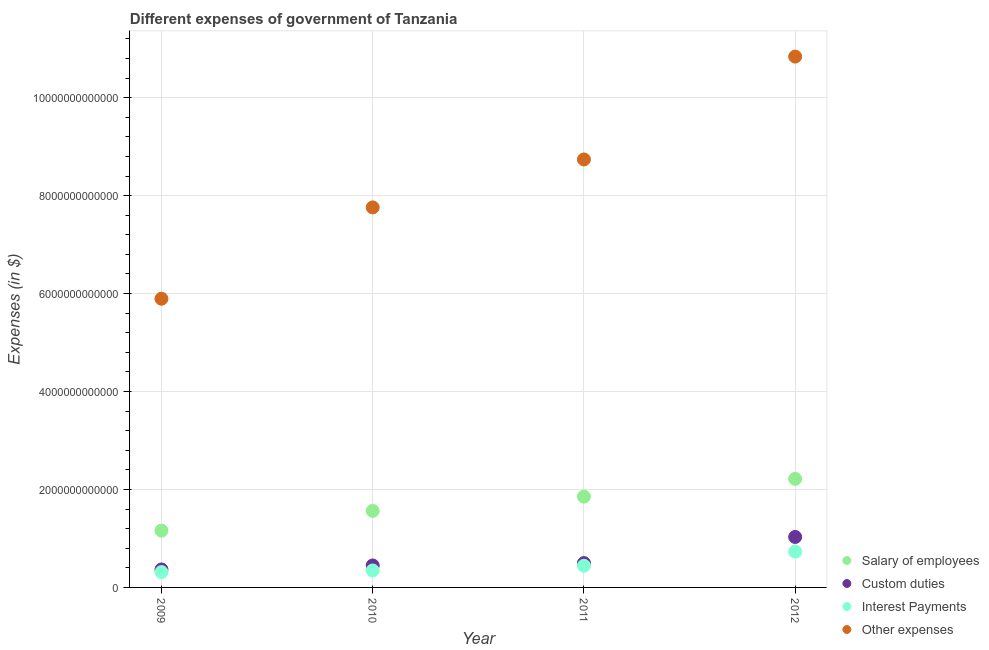How many different coloured dotlines are there?
Your response must be concise. 4. What is the amount spent on interest payments in 2009?
Provide a short and direct response. 3.14e+11. Across all years, what is the maximum amount spent on salary of employees?
Offer a very short reply. 2.22e+12. Across all years, what is the minimum amount spent on interest payments?
Offer a very short reply. 3.14e+11. In which year was the amount spent on other expenses minimum?
Offer a terse response. 2009. What is the total amount spent on salary of employees in the graph?
Provide a succinct answer. 6.79e+12. What is the difference between the amount spent on other expenses in 2010 and that in 2012?
Offer a very short reply. -3.08e+12. What is the difference between the amount spent on salary of employees in 2010 and the amount spent on other expenses in 2009?
Your answer should be compact. -4.33e+12. What is the average amount spent on salary of employees per year?
Your answer should be compact. 1.70e+12. In the year 2010, what is the difference between the amount spent on custom duties and amount spent on other expenses?
Give a very brief answer. -7.31e+12. In how many years, is the amount spent on salary of employees greater than 10000000000000 $?
Keep it short and to the point. 0. What is the ratio of the amount spent on interest payments in 2011 to that in 2012?
Your answer should be compact. 0.61. Is the amount spent on other expenses in 2009 less than that in 2010?
Your answer should be very brief. Yes. Is the difference between the amount spent on interest payments in 2010 and 2011 greater than the difference between the amount spent on other expenses in 2010 and 2011?
Offer a very short reply. Yes. What is the difference between the highest and the second highest amount spent on custom duties?
Give a very brief answer. 5.33e+11. What is the difference between the highest and the lowest amount spent on other expenses?
Your response must be concise. 4.94e+12. In how many years, is the amount spent on interest payments greater than the average amount spent on interest payments taken over all years?
Offer a terse response. 1. Is the sum of the amount spent on other expenses in 2010 and 2012 greater than the maximum amount spent on interest payments across all years?
Give a very brief answer. Yes. Is it the case that in every year, the sum of the amount spent on custom duties and amount spent on salary of employees is greater than the sum of amount spent on interest payments and amount spent on other expenses?
Offer a very short reply. No. Does the amount spent on other expenses monotonically increase over the years?
Keep it short and to the point. Yes. Is the amount spent on other expenses strictly greater than the amount spent on interest payments over the years?
Provide a succinct answer. Yes. Is the amount spent on interest payments strictly less than the amount spent on custom duties over the years?
Give a very brief answer. Yes. How many dotlines are there?
Offer a very short reply. 4. How many years are there in the graph?
Your answer should be compact. 4. What is the difference between two consecutive major ticks on the Y-axis?
Keep it short and to the point. 2.00e+12. Are the values on the major ticks of Y-axis written in scientific E-notation?
Offer a very short reply. No. Does the graph contain any zero values?
Your answer should be compact. No. Does the graph contain grids?
Give a very brief answer. Yes. How many legend labels are there?
Your answer should be compact. 4. How are the legend labels stacked?
Offer a very short reply. Vertical. What is the title of the graph?
Ensure brevity in your answer.  Different expenses of government of Tanzania. What is the label or title of the Y-axis?
Provide a succinct answer. Expenses (in $). What is the Expenses (in $) in Salary of employees in 2009?
Your response must be concise. 1.16e+12. What is the Expenses (in $) in Custom duties in 2009?
Provide a succinct answer. 3.67e+11. What is the Expenses (in $) in Interest Payments in 2009?
Make the answer very short. 3.14e+11. What is the Expenses (in $) in Other expenses in 2009?
Provide a succinct answer. 5.89e+12. What is the Expenses (in $) in Salary of employees in 2010?
Your answer should be compact. 1.56e+12. What is the Expenses (in $) in Custom duties in 2010?
Ensure brevity in your answer.  4.49e+11. What is the Expenses (in $) of Interest Payments in 2010?
Your answer should be very brief. 3.47e+11. What is the Expenses (in $) in Other expenses in 2010?
Keep it short and to the point. 7.76e+12. What is the Expenses (in $) in Salary of employees in 2011?
Your answer should be compact. 1.85e+12. What is the Expenses (in $) of Custom duties in 2011?
Provide a succinct answer. 4.98e+11. What is the Expenses (in $) in Interest Payments in 2011?
Provide a short and direct response. 4.43e+11. What is the Expenses (in $) of Other expenses in 2011?
Keep it short and to the point. 8.74e+12. What is the Expenses (in $) of Salary of employees in 2012?
Your answer should be very brief. 2.22e+12. What is the Expenses (in $) of Custom duties in 2012?
Provide a short and direct response. 1.03e+12. What is the Expenses (in $) in Interest Payments in 2012?
Provide a short and direct response. 7.31e+11. What is the Expenses (in $) in Other expenses in 2012?
Keep it short and to the point. 1.08e+13. Across all years, what is the maximum Expenses (in $) of Salary of employees?
Ensure brevity in your answer.  2.22e+12. Across all years, what is the maximum Expenses (in $) of Custom duties?
Offer a very short reply. 1.03e+12. Across all years, what is the maximum Expenses (in $) of Interest Payments?
Ensure brevity in your answer.  7.31e+11. Across all years, what is the maximum Expenses (in $) in Other expenses?
Offer a very short reply. 1.08e+13. Across all years, what is the minimum Expenses (in $) of Salary of employees?
Your response must be concise. 1.16e+12. Across all years, what is the minimum Expenses (in $) of Custom duties?
Offer a terse response. 3.67e+11. Across all years, what is the minimum Expenses (in $) in Interest Payments?
Give a very brief answer. 3.14e+11. Across all years, what is the minimum Expenses (in $) of Other expenses?
Make the answer very short. 5.89e+12. What is the total Expenses (in $) of Salary of employees in the graph?
Give a very brief answer. 6.79e+12. What is the total Expenses (in $) of Custom duties in the graph?
Provide a succinct answer. 2.34e+12. What is the total Expenses (in $) of Interest Payments in the graph?
Give a very brief answer. 1.83e+12. What is the total Expenses (in $) of Other expenses in the graph?
Offer a terse response. 3.32e+13. What is the difference between the Expenses (in $) in Salary of employees in 2009 and that in 2010?
Offer a terse response. -4.03e+11. What is the difference between the Expenses (in $) in Custom duties in 2009 and that in 2010?
Your answer should be compact. -8.16e+1. What is the difference between the Expenses (in $) of Interest Payments in 2009 and that in 2010?
Your answer should be very brief. -3.27e+1. What is the difference between the Expenses (in $) in Other expenses in 2009 and that in 2010?
Your answer should be very brief. -1.86e+12. What is the difference between the Expenses (in $) of Salary of employees in 2009 and that in 2011?
Your answer should be very brief. -6.95e+11. What is the difference between the Expenses (in $) of Custom duties in 2009 and that in 2011?
Ensure brevity in your answer.  -1.31e+11. What is the difference between the Expenses (in $) of Interest Payments in 2009 and that in 2011?
Your answer should be very brief. -1.29e+11. What is the difference between the Expenses (in $) of Other expenses in 2009 and that in 2011?
Your response must be concise. -2.84e+12. What is the difference between the Expenses (in $) of Salary of employees in 2009 and that in 2012?
Keep it short and to the point. -1.06e+12. What is the difference between the Expenses (in $) of Custom duties in 2009 and that in 2012?
Ensure brevity in your answer.  -6.63e+11. What is the difference between the Expenses (in $) in Interest Payments in 2009 and that in 2012?
Make the answer very short. -4.17e+11. What is the difference between the Expenses (in $) in Other expenses in 2009 and that in 2012?
Provide a short and direct response. -4.94e+12. What is the difference between the Expenses (in $) of Salary of employees in 2010 and that in 2011?
Make the answer very short. -2.92e+11. What is the difference between the Expenses (in $) of Custom duties in 2010 and that in 2011?
Your response must be concise. -4.90e+1. What is the difference between the Expenses (in $) of Interest Payments in 2010 and that in 2011?
Your answer should be compact. -9.59e+1. What is the difference between the Expenses (in $) in Other expenses in 2010 and that in 2011?
Make the answer very short. -9.79e+11. What is the difference between the Expenses (in $) of Salary of employees in 2010 and that in 2012?
Ensure brevity in your answer.  -6.53e+11. What is the difference between the Expenses (in $) of Custom duties in 2010 and that in 2012?
Make the answer very short. -5.82e+11. What is the difference between the Expenses (in $) in Interest Payments in 2010 and that in 2012?
Keep it short and to the point. -3.85e+11. What is the difference between the Expenses (in $) of Other expenses in 2010 and that in 2012?
Your answer should be very brief. -3.08e+12. What is the difference between the Expenses (in $) in Salary of employees in 2011 and that in 2012?
Your answer should be very brief. -3.62e+11. What is the difference between the Expenses (in $) of Custom duties in 2011 and that in 2012?
Keep it short and to the point. -5.33e+11. What is the difference between the Expenses (in $) of Interest Payments in 2011 and that in 2012?
Offer a very short reply. -2.89e+11. What is the difference between the Expenses (in $) in Other expenses in 2011 and that in 2012?
Provide a short and direct response. -2.10e+12. What is the difference between the Expenses (in $) of Salary of employees in 2009 and the Expenses (in $) of Custom duties in 2010?
Ensure brevity in your answer.  7.11e+11. What is the difference between the Expenses (in $) of Salary of employees in 2009 and the Expenses (in $) of Interest Payments in 2010?
Make the answer very short. 8.13e+11. What is the difference between the Expenses (in $) of Salary of employees in 2009 and the Expenses (in $) of Other expenses in 2010?
Your response must be concise. -6.60e+12. What is the difference between the Expenses (in $) of Custom duties in 2009 and the Expenses (in $) of Interest Payments in 2010?
Ensure brevity in your answer.  2.03e+1. What is the difference between the Expenses (in $) in Custom duties in 2009 and the Expenses (in $) in Other expenses in 2010?
Your answer should be very brief. -7.39e+12. What is the difference between the Expenses (in $) of Interest Payments in 2009 and the Expenses (in $) of Other expenses in 2010?
Make the answer very short. -7.45e+12. What is the difference between the Expenses (in $) in Salary of employees in 2009 and the Expenses (in $) in Custom duties in 2011?
Give a very brief answer. 6.62e+11. What is the difference between the Expenses (in $) in Salary of employees in 2009 and the Expenses (in $) in Interest Payments in 2011?
Offer a terse response. 7.17e+11. What is the difference between the Expenses (in $) of Salary of employees in 2009 and the Expenses (in $) of Other expenses in 2011?
Make the answer very short. -7.58e+12. What is the difference between the Expenses (in $) in Custom duties in 2009 and the Expenses (in $) in Interest Payments in 2011?
Offer a very short reply. -7.56e+1. What is the difference between the Expenses (in $) of Custom duties in 2009 and the Expenses (in $) of Other expenses in 2011?
Make the answer very short. -8.37e+12. What is the difference between the Expenses (in $) in Interest Payments in 2009 and the Expenses (in $) in Other expenses in 2011?
Offer a very short reply. -8.42e+12. What is the difference between the Expenses (in $) in Salary of employees in 2009 and the Expenses (in $) in Custom duties in 2012?
Provide a succinct answer. 1.29e+11. What is the difference between the Expenses (in $) in Salary of employees in 2009 and the Expenses (in $) in Interest Payments in 2012?
Give a very brief answer. 4.28e+11. What is the difference between the Expenses (in $) of Salary of employees in 2009 and the Expenses (in $) of Other expenses in 2012?
Give a very brief answer. -9.68e+12. What is the difference between the Expenses (in $) in Custom duties in 2009 and the Expenses (in $) in Interest Payments in 2012?
Ensure brevity in your answer.  -3.64e+11. What is the difference between the Expenses (in $) of Custom duties in 2009 and the Expenses (in $) of Other expenses in 2012?
Offer a very short reply. -1.05e+13. What is the difference between the Expenses (in $) of Interest Payments in 2009 and the Expenses (in $) of Other expenses in 2012?
Give a very brief answer. -1.05e+13. What is the difference between the Expenses (in $) of Salary of employees in 2010 and the Expenses (in $) of Custom duties in 2011?
Provide a short and direct response. 1.07e+12. What is the difference between the Expenses (in $) of Salary of employees in 2010 and the Expenses (in $) of Interest Payments in 2011?
Offer a very short reply. 1.12e+12. What is the difference between the Expenses (in $) in Salary of employees in 2010 and the Expenses (in $) in Other expenses in 2011?
Ensure brevity in your answer.  -7.18e+12. What is the difference between the Expenses (in $) of Custom duties in 2010 and the Expenses (in $) of Interest Payments in 2011?
Keep it short and to the point. 5.99e+09. What is the difference between the Expenses (in $) of Custom duties in 2010 and the Expenses (in $) of Other expenses in 2011?
Ensure brevity in your answer.  -8.29e+12. What is the difference between the Expenses (in $) of Interest Payments in 2010 and the Expenses (in $) of Other expenses in 2011?
Provide a succinct answer. -8.39e+12. What is the difference between the Expenses (in $) in Salary of employees in 2010 and the Expenses (in $) in Custom duties in 2012?
Your answer should be compact. 5.33e+11. What is the difference between the Expenses (in $) in Salary of employees in 2010 and the Expenses (in $) in Interest Payments in 2012?
Keep it short and to the point. 8.32e+11. What is the difference between the Expenses (in $) in Salary of employees in 2010 and the Expenses (in $) in Other expenses in 2012?
Your answer should be compact. -9.28e+12. What is the difference between the Expenses (in $) of Custom duties in 2010 and the Expenses (in $) of Interest Payments in 2012?
Provide a short and direct response. -2.83e+11. What is the difference between the Expenses (in $) in Custom duties in 2010 and the Expenses (in $) in Other expenses in 2012?
Your answer should be compact. -1.04e+13. What is the difference between the Expenses (in $) in Interest Payments in 2010 and the Expenses (in $) in Other expenses in 2012?
Provide a short and direct response. -1.05e+13. What is the difference between the Expenses (in $) of Salary of employees in 2011 and the Expenses (in $) of Custom duties in 2012?
Your response must be concise. 8.24e+11. What is the difference between the Expenses (in $) in Salary of employees in 2011 and the Expenses (in $) in Interest Payments in 2012?
Ensure brevity in your answer.  1.12e+12. What is the difference between the Expenses (in $) of Salary of employees in 2011 and the Expenses (in $) of Other expenses in 2012?
Provide a short and direct response. -8.98e+12. What is the difference between the Expenses (in $) of Custom duties in 2011 and the Expenses (in $) of Interest Payments in 2012?
Provide a succinct answer. -2.34e+11. What is the difference between the Expenses (in $) in Custom duties in 2011 and the Expenses (in $) in Other expenses in 2012?
Make the answer very short. -1.03e+13. What is the difference between the Expenses (in $) in Interest Payments in 2011 and the Expenses (in $) in Other expenses in 2012?
Provide a short and direct response. -1.04e+13. What is the average Expenses (in $) of Salary of employees per year?
Make the answer very short. 1.70e+12. What is the average Expenses (in $) of Custom duties per year?
Offer a terse response. 5.86e+11. What is the average Expenses (in $) of Interest Payments per year?
Ensure brevity in your answer.  4.59e+11. What is the average Expenses (in $) of Other expenses per year?
Offer a terse response. 8.31e+12. In the year 2009, what is the difference between the Expenses (in $) of Salary of employees and Expenses (in $) of Custom duties?
Your response must be concise. 7.93e+11. In the year 2009, what is the difference between the Expenses (in $) in Salary of employees and Expenses (in $) in Interest Payments?
Offer a terse response. 8.46e+11. In the year 2009, what is the difference between the Expenses (in $) in Salary of employees and Expenses (in $) in Other expenses?
Offer a very short reply. -4.73e+12. In the year 2009, what is the difference between the Expenses (in $) of Custom duties and Expenses (in $) of Interest Payments?
Provide a succinct answer. 5.31e+1. In the year 2009, what is the difference between the Expenses (in $) of Custom duties and Expenses (in $) of Other expenses?
Provide a succinct answer. -5.53e+12. In the year 2009, what is the difference between the Expenses (in $) of Interest Payments and Expenses (in $) of Other expenses?
Offer a terse response. -5.58e+12. In the year 2010, what is the difference between the Expenses (in $) of Salary of employees and Expenses (in $) of Custom duties?
Make the answer very short. 1.11e+12. In the year 2010, what is the difference between the Expenses (in $) in Salary of employees and Expenses (in $) in Interest Payments?
Keep it short and to the point. 1.22e+12. In the year 2010, what is the difference between the Expenses (in $) of Salary of employees and Expenses (in $) of Other expenses?
Offer a terse response. -6.20e+12. In the year 2010, what is the difference between the Expenses (in $) of Custom duties and Expenses (in $) of Interest Payments?
Give a very brief answer. 1.02e+11. In the year 2010, what is the difference between the Expenses (in $) of Custom duties and Expenses (in $) of Other expenses?
Offer a very short reply. -7.31e+12. In the year 2010, what is the difference between the Expenses (in $) of Interest Payments and Expenses (in $) of Other expenses?
Give a very brief answer. -7.41e+12. In the year 2011, what is the difference between the Expenses (in $) in Salary of employees and Expenses (in $) in Custom duties?
Offer a very short reply. 1.36e+12. In the year 2011, what is the difference between the Expenses (in $) in Salary of employees and Expenses (in $) in Interest Payments?
Make the answer very short. 1.41e+12. In the year 2011, what is the difference between the Expenses (in $) of Salary of employees and Expenses (in $) of Other expenses?
Offer a terse response. -6.88e+12. In the year 2011, what is the difference between the Expenses (in $) in Custom duties and Expenses (in $) in Interest Payments?
Your answer should be very brief. 5.50e+1. In the year 2011, what is the difference between the Expenses (in $) of Custom duties and Expenses (in $) of Other expenses?
Provide a succinct answer. -8.24e+12. In the year 2011, what is the difference between the Expenses (in $) in Interest Payments and Expenses (in $) in Other expenses?
Your answer should be very brief. -8.30e+12. In the year 2012, what is the difference between the Expenses (in $) in Salary of employees and Expenses (in $) in Custom duties?
Your answer should be compact. 1.19e+12. In the year 2012, what is the difference between the Expenses (in $) in Salary of employees and Expenses (in $) in Interest Payments?
Give a very brief answer. 1.49e+12. In the year 2012, what is the difference between the Expenses (in $) in Salary of employees and Expenses (in $) in Other expenses?
Offer a terse response. -8.62e+12. In the year 2012, what is the difference between the Expenses (in $) of Custom duties and Expenses (in $) of Interest Payments?
Your answer should be very brief. 2.99e+11. In the year 2012, what is the difference between the Expenses (in $) of Custom duties and Expenses (in $) of Other expenses?
Ensure brevity in your answer.  -9.81e+12. In the year 2012, what is the difference between the Expenses (in $) in Interest Payments and Expenses (in $) in Other expenses?
Make the answer very short. -1.01e+13. What is the ratio of the Expenses (in $) of Salary of employees in 2009 to that in 2010?
Provide a succinct answer. 0.74. What is the ratio of the Expenses (in $) in Custom duties in 2009 to that in 2010?
Provide a short and direct response. 0.82. What is the ratio of the Expenses (in $) in Interest Payments in 2009 to that in 2010?
Provide a short and direct response. 0.91. What is the ratio of the Expenses (in $) in Other expenses in 2009 to that in 2010?
Give a very brief answer. 0.76. What is the ratio of the Expenses (in $) of Salary of employees in 2009 to that in 2011?
Your answer should be compact. 0.63. What is the ratio of the Expenses (in $) of Custom duties in 2009 to that in 2011?
Your response must be concise. 0.74. What is the ratio of the Expenses (in $) of Interest Payments in 2009 to that in 2011?
Ensure brevity in your answer.  0.71. What is the ratio of the Expenses (in $) in Other expenses in 2009 to that in 2011?
Provide a succinct answer. 0.67. What is the ratio of the Expenses (in $) of Salary of employees in 2009 to that in 2012?
Ensure brevity in your answer.  0.52. What is the ratio of the Expenses (in $) in Custom duties in 2009 to that in 2012?
Offer a very short reply. 0.36. What is the ratio of the Expenses (in $) in Interest Payments in 2009 to that in 2012?
Ensure brevity in your answer.  0.43. What is the ratio of the Expenses (in $) in Other expenses in 2009 to that in 2012?
Offer a terse response. 0.54. What is the ratio of the Expenses (in $) of Salary of employees in 2010 to that in 2011?
Your response must be concise. 0.84. What is the ratio of the Expenses (in $) of Custom duties in 2010 to that in 2011?
Provide a short and direct response. 0.9. What is the ratio of the Expenses (in $) in Interest Payments in 2010 to that in 2011?
Ensure brevity in your answer.  0.78. What is the ratio of the Expenses (in $) in Other expenses in 2010 to that in 2011?
Provide a short and direct response. 0.89. What is the ratio of the Expenses (in $) of Salary of employees in 2010 to that in 2012?
Your answer should be compact. 0.71. What is the ratio of the Expenses (in $) in Custom duties in 2010 to that in 2012?
Give a very brief answer. 0.44. What is the ratio of the Expenses (in $) of Interest Payments in 2010 to that in 2012?
Give a very brief answer. 0.47. What is the ratio of the Expenses (in $) of Other expenses in 2010 to that in 2012?
Your answer should be very brief. 0.72. What is the ratio of the Expenses (in $) of Salary of employees in 2011 to that in 2012?
Offer a very short reply. 0.84. What is the ratio of the Expenses (in $) of Custom duties in 2011 to that in 2012?
Offer a very short reply. 0.48. What is the ratio of the Expenses (in $) in Interest Payments in 2011 to that in 2012?
Make the answer very short. 0.61. What is the ratio of the Expenses (in $) in Other expenses in 2011 to that in 2012?
Your answer should be compact. 0.81. What is the difference between the highest and the second highest Expenses (in $) in Salary of employees?
Provide a short and direct response. 3.62e+11. What is the difference between the highest and the second highest Expenses (in $) of Custom duties?
Give a very brief answer. 5.33e+11. What is the difference between the highest and the second highest Expenses (in $) of Interest Payments?
Your answer should be compact. 2.89e+11. What is the difference between the highest and the second highest Expenses (in $) in Other expenses?
Give a very brief answer. 2.10e+12. What is the difference between the highest and the lowest Expenses (in $) in Salary of employees?
Your answer should be compact. 1.06e+12. What is the difference between the highest and the lowest Expenses (in $) in Custom duties?
Your answer should be very brief. 6.63e+11. What is the difference between the highest and the lowest Expenses (in $) of Interest Payments?
Keep it short and to the point. 4.17e+11. What is the difference between the highest and the lowest Expenses (in $) in Other expenses?
Your answer should be very brief. 4.94e+12. 